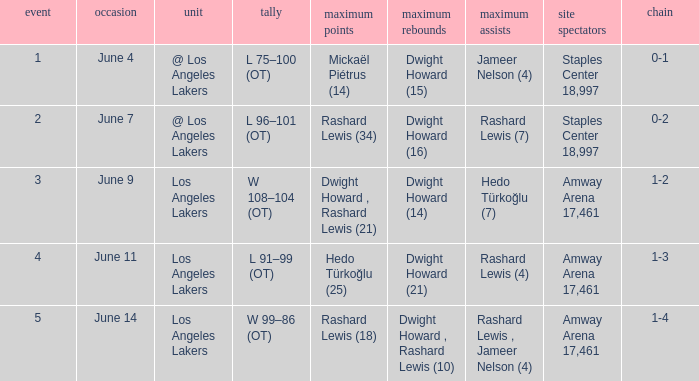What is High Assists, when High Rebounds is "Dwight Howard , Rashard Lewis (10)"? Rashard Lewis , Jameer Nelson (4). 